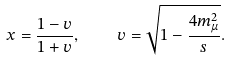<formula> <loc_0><loc_0><loc_500><loc_500>x = \frac { 1 - v } { 1 + v } , \quad v = \sqrt { 1 - \frac { 4 m _ { \mu } ^ { 2 } } s } .</formula> 